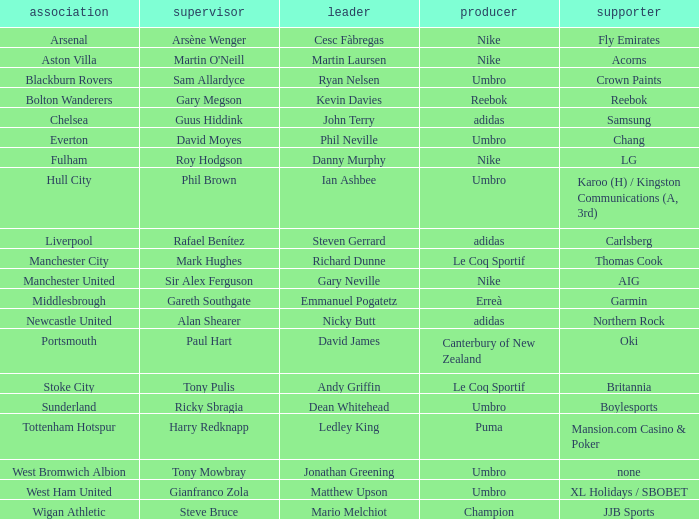In which team does ledley king serve as a captain? Tottenham Hotspur. 